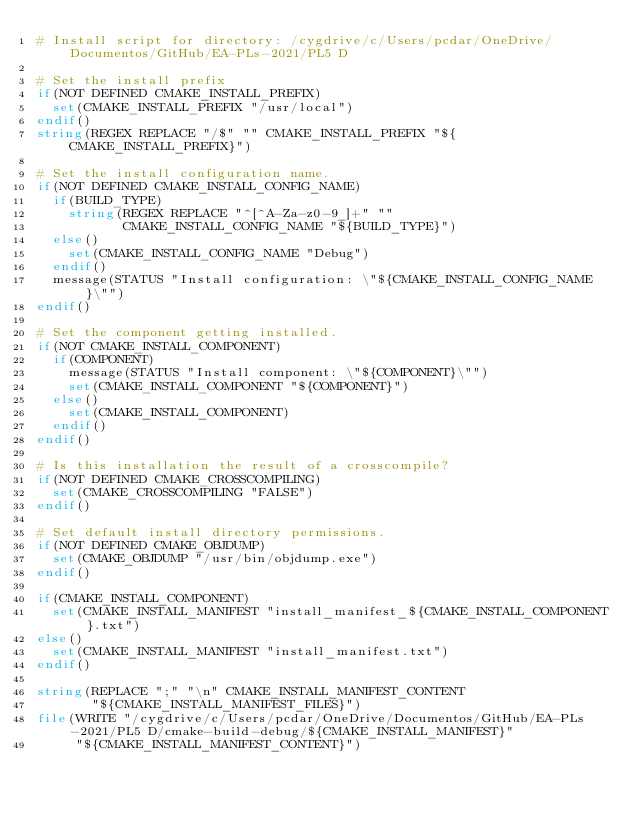<code> <loc_0><loc_0><loc_500><loc_500><_CMake_># Install script for directory: /cygdrive/c/Users/pcdar/OneDrive/Documentos/GitHub/EA-PLs-2021/PL5 D

# Set the install prefix
if(NOT DEFINED CMAKE_INSTALL_PREFIX)
  set(CMAKE_INSTALL_PREFIX "/usr/local")
endif()
string(REGEX REPLACE "/$" "" CMAKE_INSTALL_PREFIX "${CMAKE_INSTALL_PREFIX}")

# Set the install configuration name.
if(NOT DEFINED CMAKE_INSTALL_CONFIG_NAME)
  if(BUILD_TYPE)
    string(REGEX REPLACE "^[^A-Za-z0-9_]+" ""
           CMAKE_INSTALL_CONFIG_NAME "${BUILD_TYPE}")
  else()
    set(CMAKE_INSTALL_CONFIG_NAME "Debug")
  endif()
  message(STATUS "Install configuration: \"${CMAKE_INSTALL_CONFIG_NAME}\"")
endif()

# Set the component getting installed.
if(NOT CMAKE_INSTALL_COMPONENT)
  if(COMPONENT)
    message(STATUS "Install component: \"${COMPONENT}\"")
    set(CMAKE_INSTALL_COMPONENT "${COMPONENT}")
  else()
    set(CMAKE_INSTALL_COMPONENT)
  endif()
endif()

# Is this installation the result of a crosscompile?
if(NOT DEFINED CMAKE_CROSSCOMPILING)
  set(CMAKE_CROSSCOMPILING "FALSE")
endif()

# Set default install directory permissions.
if(NOT DEFINED CMAKE_OBJDUMP)
  set(CMAKE_OBJDUMP "/usr/bin/objdump.exe")
endif()

if(CMAKE_INSTALL_COMPONENT)
  set(CMAKE_INSTALL_MANIFEST "install_manifest_${CMAKE_INSTALL_COMPONENT}.txt")
else()
  set(CMAKE_INSTALL_MANIFEST "install_manifest.txt")
endif()

string(REPLACE ";" "\n" CMAKE_INSTALL_MANIFEST_CONTENT
       "${CMAKE_INSTALL_MANIFEST_FILES}")
file(WRITE "/cygdrive/c/Users/pcdar/OneDrive/Documentos/GitHub/EA-PLs-2021/PL5 D/cmake-build-debug/${CMAKE_INSTALL_MANIFEST}"
     "${CMAKE_INSTALL_MANIFEST_CONTENT}")
</code> 